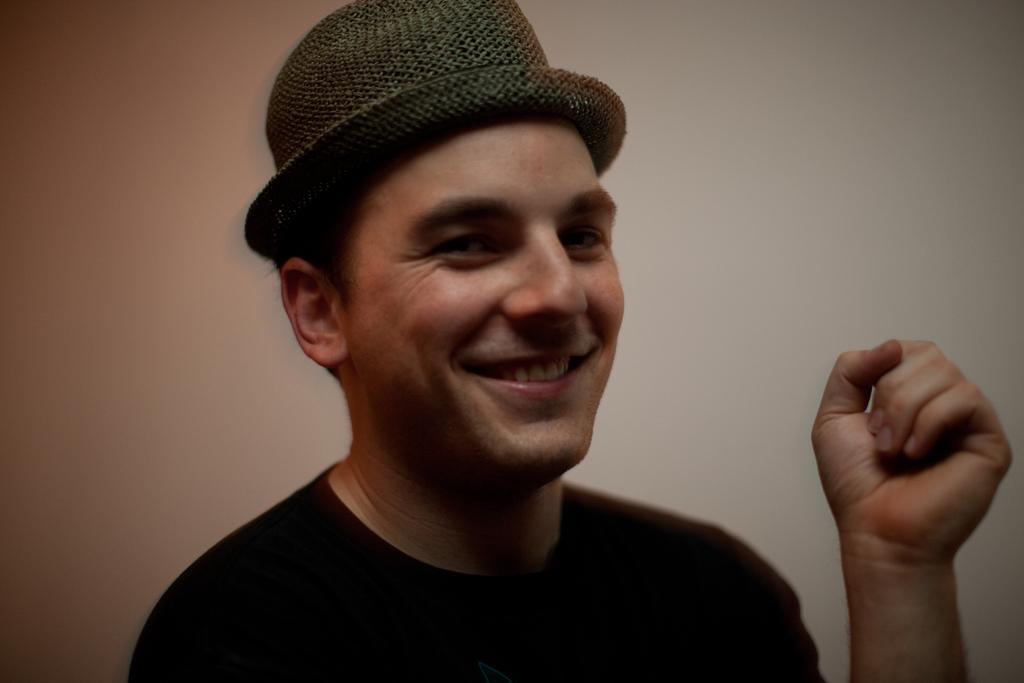Who is present in the image? There is a person in the image. What is the person doing in the image? The person is smiling. What type of clothing accessory is the person wearing? The person is wearing a cap. What can be seen in the background of the image? There is a white color wall in the background of the image. What statement does the person make in the image? There is no statement made by the person in the image; we can only observe their smile and cap. 